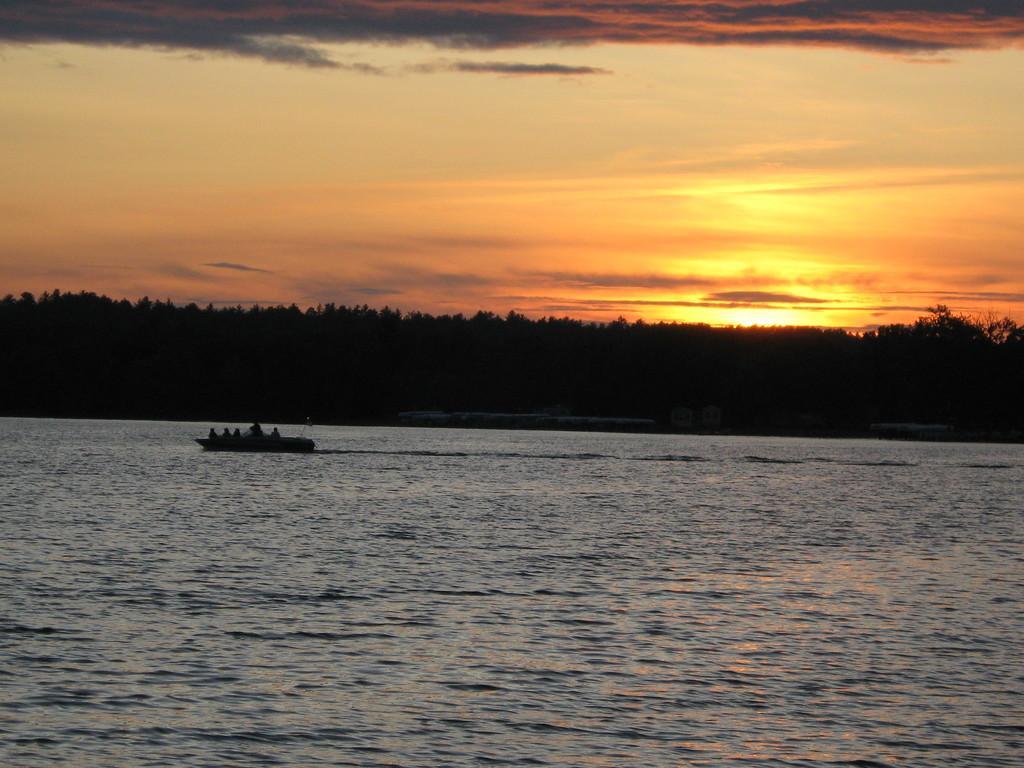How would you summarize this image in a sentence or two? In this image, we can see a ship with some people in it and it is sailing on the water. We can also see some trees and the sky. 